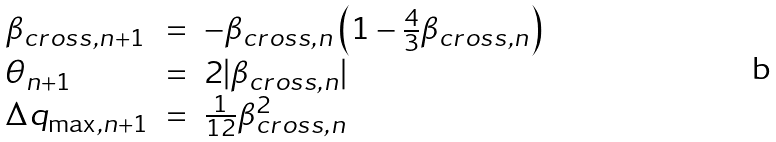Convert formula to latex. <formula><loc_0><loc_0><loc_500><loc_500>\begin{array} { l c l } \beta _ { c r o s s , n + 1 } & = & - \beta _ { c r o s s , n } \left ( 1 - \frac { 4 } { 3 } \beta _ { c r o s s , n } \right ) \\ \theta _ { n + 1 } & = & 2 | \beta _ { c r o s s , n } | \\ \Delta q _ { \max , n + 1 } & = & \frac { 1 } { 1 2 } \beta _ { c r o s s , n } ^ { 2 } \end{array}</formula> 